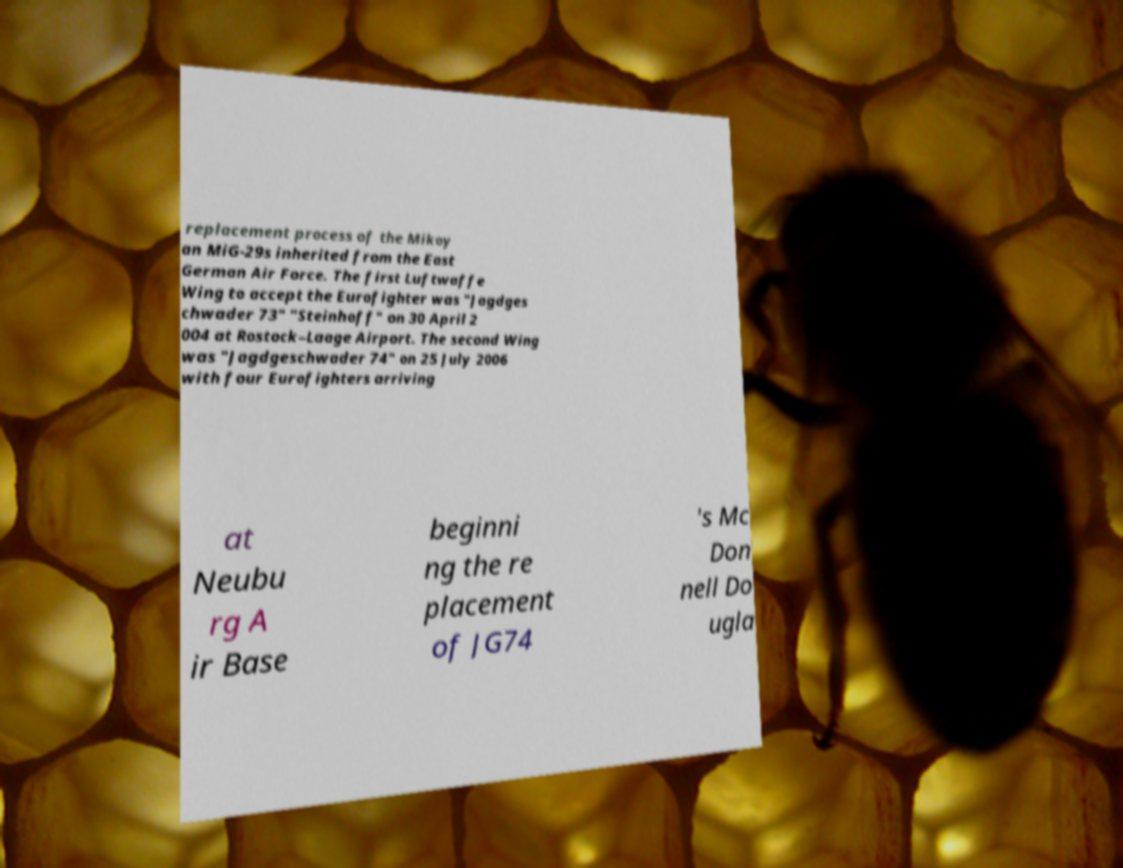Could you extract and type out the text from this image? replacement process of the Mikoy an MiG-29s inherited from the East German Air Force. The first Luftwaffe Wing to accept the Eurofighter was "Jagdges chwader 73" "Steinhoff" on 30 April 2 004 at Rostock–Laage Airport. The second Wing was "Jagdgeschwader 74" on 25 July 2006 with four Eurofighters arriving at Neubu rg A ir Base beginni ng the re placement of JG74 's Mc Don nell Do ugla 